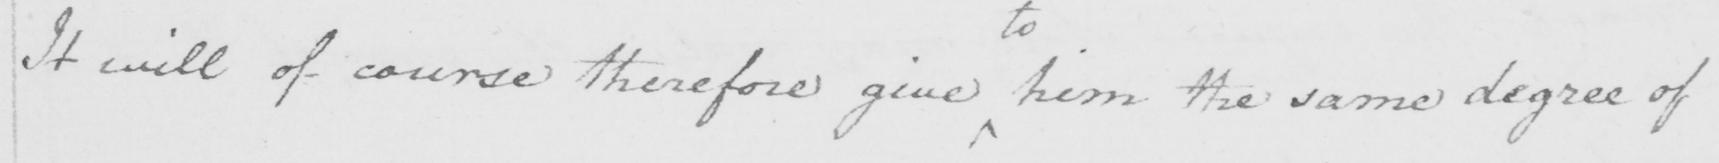What is written in this line of handwriting? It will of course therefore give him the same degree of 